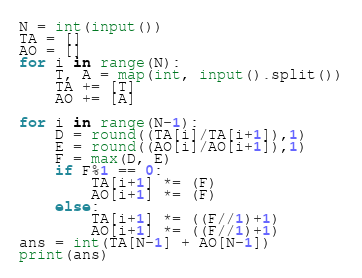<code> <loc_0><loc_0><loc_500><loc_500><_Python_>N = int(input())
TA = []
AO = []
for i in range(N):
    T, A = map(int, input().split())
    TA += [T]
    AO += [A]

for i in range(N-1):
    D = round((TA[i]/TA[i+1]),1)
    E = round((AO[i]/AO[i+1]),1)
    F = max(D, E)
    if F%1 == 0:
        TA[i+1] *= (F)
        AO[i+1] *= (F)
    else:
        TA[i+1] *= ((F//1)+1)
        AO[i+1] *= ((F//1)+1)
ans = int(TA[N-1] + AO[N-1])
print(ans)</code> 